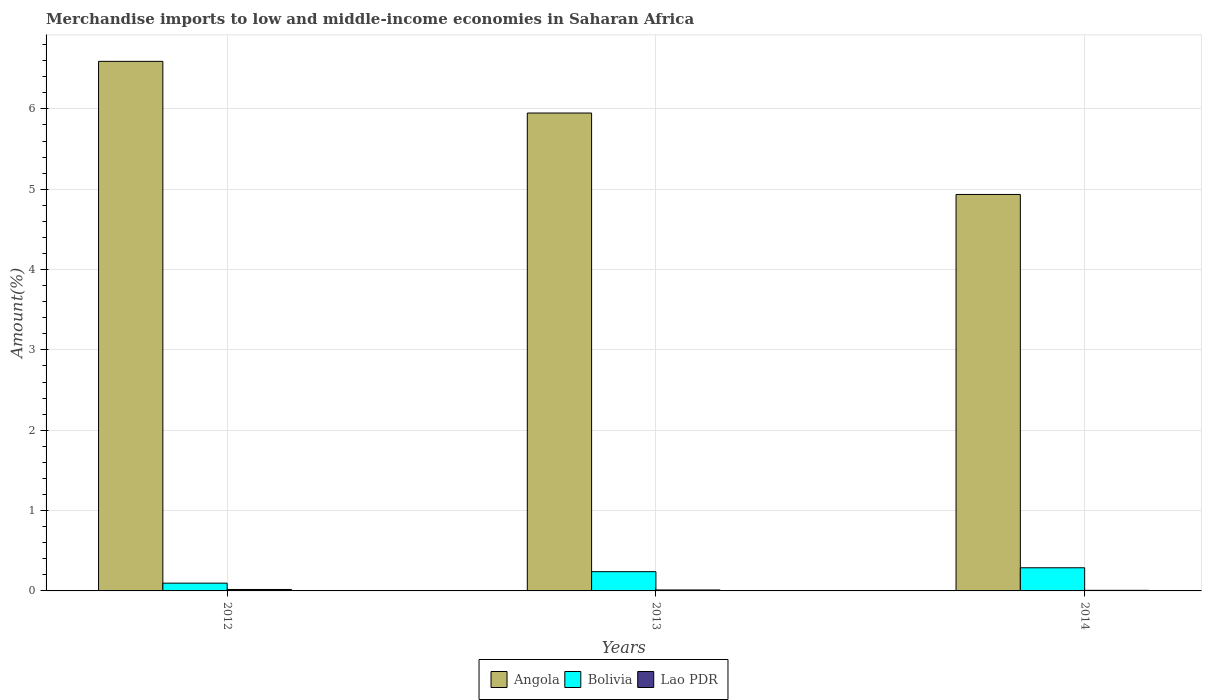How many groups of bars are there?
Make the answer very short. 3. What is the percentage of amount earned from merchandise imports in Lao PDR in 2012?
Make the answer very short. 0.02. Across all years, what is the maximum percentage of amount earned from merchandise imports in Lao PDR?
Offer a very short reply. 0.02. Across all years, what is the minimum percentage of amount earned from merchandise imports in Lao PDR?
Offer a terse response. 0.01. In which year was the percentage of amount earned from merchandise imports in Bolivia maximum?
Keep it short and to the point. 2014. In which year was the percentage of amount earned from merchandise imports in Lao PDR minimum?
Your response must be concise. 2014. What is the total percentage of amount earned from merchandise imports in Angola in the graph?
Your answer should be compact. 17.48. What is the difference between the percentage of amount earned from merchandise imports in Angola in 2012 and that in 2014?
Offer a terse response. 1.66. What is the difference between the percentage of amount earned from merchandise imports in Lao PDR in 2014 and the percentage of amount earned from merchandise imports in Angola in 2013?
Your answer should be very brief. -5.94. What is the average percentage of amount earned from merchandise imports in Bolivia per year?
Your response must be concise. 0.21. In the year 2013, what is the difference between the percentage of amount earned from merchandise imports in Angola and percentage of amount earned from merchandise imports in Lao PDR?
Your answer should be compact. 5.94. What is the ratio of the percentage of amount earned from merchandise imports in Lao PDR in 2012 to that in 2013?
Make the answer very short. 1.52. Is the percentage of amount earned from merchandise imports in Lao PDR in 2013 less than that in 2014?
Make the answer very short. No. Is the difference between the percentage of amount earned from merchandise imports in Angola in 2013 and 2014 greater than the difference between the percentage of amount earned from merchandise imports in Lao PDR in 2013 and 2014?
Your answer should be compact. Yes. What is the difference between the highest and the second highest percentage of amount earned from merchandise imports in Angola?
Provide a succinct answer. 0.64. What is the difference between the highest and the lowest percentage of amount earned from merchandise imports in Lao PDR?
Make the answer very short. 0.01. What does the 3rd bar from the left in 2012 represents?
Offer a very short reply. Lao PDR. Is it the case that in every year, the sum of the percentage of amount earned from merchandise imports in Lao PDR and percentage of amount earned from merchandise imports in Bolivia is greater than the percentage of amount earned from merchandise imports in Angola?
Give a very brief answer. No. How many years are there in the graph?
Your answer should be very brief. 3. What is the difference between two consecutive major ticks on the Y-axis?
Offer a terse response. 1. Does the graph contain any zero values?
Offer a terse response. No. Does the graph contain grids?
Keep it short and to the point. Yes. How many legend labels are there?
Your answer should be very brief. 3. How are the legend labels stacked?
Give a very brief answer. Horizontal. What is the title of the graph?
Offer a terse response. Merchandise imports to low and middle-income economies in Saharan Africa. What is the label or title of the Y-axis?
Offer a very short reply. Amount(%). What is the Amount(%) of Angola in 2012?
Your answer should be very brief. 6.59. What is the Amount(%) in Bolivia in 2012?
Your response must be concise. 0.1. What is the Amount(%) in Lao PDR in 2012?
Provide a short and direct response. 0.02. What is the Amount(%) in Angola in 2013?
Your answer should be compact. 5.95. What is the Amount(%) in Bolivia in 2013?
Your answer should be compact. 0.24. What is the Amount(%) in Lao PDR in 2013?
Offer a terse response. 0.01. What is the Amount(%) in Angola in 2014?
Your answer should be very brief. 4.93. What is the Amount(%) of Bolivia in 2014?
Ensure brevity in your answer.  0.29. What is the Amount(%) in Lao PDR in 2014?
Provide a short and direct response. 0.01. Across all years, what is the maximum Amount(%) in Angola?
Ensure brevity in your answer.  6.59. Across all years, what is the maximum Amount(%) in Bolivia?
Provide a short and direct response. 0.29. Across all years, what is the maximum Amount(%) in Lao PDR?
Make the answer very short. 0.02. Across all years, what is the minimum Amount(%) of Angola?
Give a very brief answer. 4.93. Across all years, what is the minimum Amount(%) in Bolivia?
Offer a very short reply. 0.1. Across all years, what is the minimum Amount(%) of Lao PDR?
Provide a succinct answer. 0.01. What is the total Amount(%) of Angola in the graph?
Your answer should be compact. 17.48. What is the total Amount(%) in Bolivia in the graph?
Keep it short and to the point. 0.62. What is the total Amount(%) of Lao PDR in the graph?
Your response must be concise. 0.04. What is the difference between the Amount(%) in Angola in 2012 and that in 2013?
Ensure brevity in your answer.  0.64. What is the difference between the Amount(%) in Bolivia in 2012 and that in 2013?
Ensure brevity in your answer.  -0.14. What is the difference between the Amount(%) in Lao PDR in 2012 and that in 2013?
Your answer should be compact. 0.01. What is the difference between the Amount(%) of Angola in 2012 and that in 2014?
Offer a very short reply. 1.66. What is the difference between the Amount(%) of Bolivia in 2012 and that in 2014?
Give a very brief answer. -0.19. What is the difference between the Amount(%) in Lao PDR in 2012 and that in 2014?
Give a very brief answer. 0.01. What is the difference between the Amount(%) in Angola in 2013 and that in 2014?
Your answer should be compact. 1.01. What is the difference between the Amount(%) in Bolivia in 2013 and that in 2014?
Provide a succinct answer. -0.05. What is the difference between the Amount(%) in Lao PDR in 2013 and that in 2014?
Provide a succinct answer. 0. What is the difference between the Amount(%) in Angola in 2012 and the Amount(%) in Bolivia in 2013?
Your answer should be very brief. 6.35. What is the difference between the Amount(%) in Angola in 2012 and the Amount(%) in Lao PDR in 2013?
Make the answer very short. 6.58. What is the difference between the Amount(%) in Bolivia in 2012 and the Amount(%) in Lao PDR in 2013?
Ensure brevity in your answer.  0.09. What is the difference between the Amount(%) in Angola in 2012 and the Amount(%) in Bolivia in 2014?
Make the answer very short. 6.3. What is the difference between the Amount(%) in Angola in 2012 and the Amount(%) in Lao PDR in 2014?
Ensure brevity in your answer.  6.58. What is the difference between the Amount(%) of Bolivia in 2012 and the Amount(%) of Lao PDR in 2014?
Offer a terse response. 0.09. What is the difference between the Amount(%) in Angola in 2013 and the Amount(%) in Bolivia in 2014?
Give a very brief answer. 5.66. What is the difference between the Amount(%) of Angola in 2013 and the Amount(%) of Lao PDR in 2014?
Make the answer very short. 5.94. What is the difference between the Amount(%) in Bolivia in 2013 and the Amount(%) in Lao PDR in 2014?
Provide a succinct answer. 0.23. What is the average Amount(%) in Angola per year?
Ensure brevity in your answer.  5.83. What is the average Amount(%) of Bolivia per year?
Give a very brief answer. 0.21. What is the average Amount(%) of Lao PDR per year?
Give a very brief answer. 0.01. In the year 2012, what is the difference between the Amount(%) in Angola and Amount(%) in Bolivia?
Offer a very short reply. 6.5. In the year 2012, what is the difference between the Amount(%) of Angola and Amount(%) of Lao PDR?
Keep it short and to the point. 6.57. In the year 2012, what is the difference between the Amount(%) of Bolivia and Amount(%) of Lao PDR?
Your answer should be very brief. 0.08. In the year 2013, what is the difference between the Amount(%) in Angola and Amount(%) in Bolivia?
Your answer should be compact. 5.71. In the year 2013, what is the difference between the Amount(%) in Angola and Amount(%) in Lao PDR?
Offer a very short reply. 5.94. In the year 2013, what is the difference between the Amount(%) of Bolivia and Amount(%) of Lao PDR?
Give a very brief answer. 0.23. In the year 2014, what is the difference between the Amount(%) of Angola and Amount(%) of Bolivia?
Offer a very short reply. 4.65. In the year 2014, what is the difference between the Amount(%) in Angola and Amount(%) in Lao PDR?
Your response must be concise. 4.93. In the year 2014, what is the difference between the Amount(%) of Bolivia and Amount(%) of Lao PDR?
Provide a short and direct response. 0.28. What is the ratio of the Amount(%) of Angola in 2012 to that in 2013?
Your answer should be compact. 1.11. What is the ratio of the Amount(%) of Bolivia in 2012 to that in 2013?
Your answer should be very brief. 0.4. What is the ratio of the Amount(%) in Lao PDR in 2012 to that in 2013?
Your response must be concise. 1.52. What is the ratio of the Amount(%) of Angola in 2012 to that in 2014?
Your response must be concise. 1.34. What is the ratio of the Amount(%) of Bolivia in 2012 to that in 2014?
Offer a terse response. 0.34. What is the ratio of the Amount(%) in Lao PDR in 2012 to that in 2014?
Provide a succinct answer. 2.48. What is the ratio of the Amount(%) in Angola in 2013 to that in 2014?
Ensure brevity in your answer.  1.21. What is the ratio of the Amount(%) of Bolivia in 2013 to that in 2014?
Ensure brevity in your answer.  0.83. What is the ratio of the Amount(%) of Lao PDR in 2013 to that in 2014?
Provide a short and direct response. 1.63. What is the difference between the highest and the second highest Amount(%) in Angola?
Provide a short and direct response. 0.64. What is the difference between the highest and the second highest Amount(%) in Bolivia?
Offer a very short reply. 0.05. What is the difference between the highest and the second highest Amount(%) of Lao PDR?
Make the answer very short. 0.01. What is the difference between the highest and the lowest Amount(%) in Angola?
Your answer should be very brief. 1.66. What is the difference between the highest and the lowest Amount(%) in Bolivia?
Your answer should be compact. 0.19. What is the difference between the highest and the lowest Amount(%) of Lao PDR?
Keep it short and to the point. 0.01. 